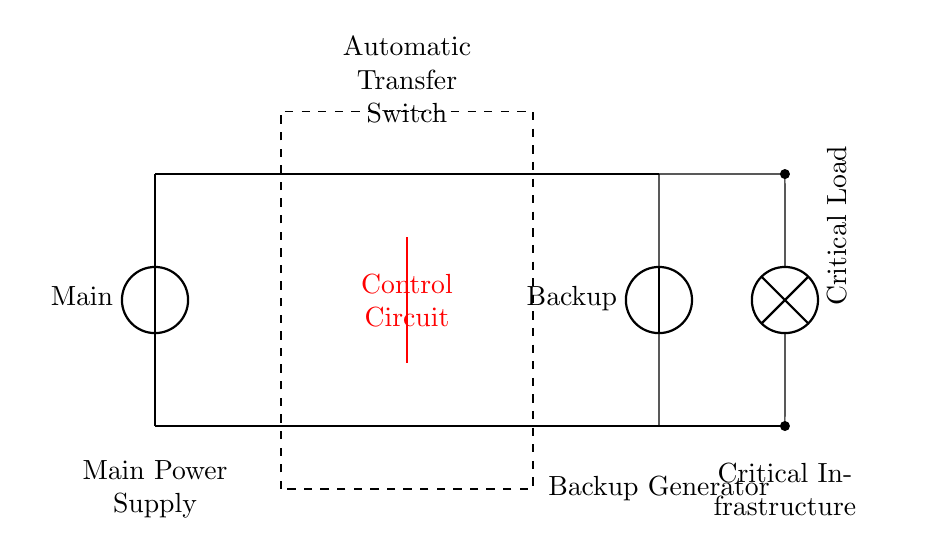What is the role of the Automatic Transfer Switch in this circuit? The Automatic Transfer Switch switches the load between the main power supply and the backup generator based on availability, ensuring uninterrupted power supply to critical infrastructure during emergencies.
Answer: Switching the load What type of load is represented in this circuit? The circuit diagram shows a critical load, which typically refers to essential electrical equipment that must remain operational even during power failures.
Answer: Critical load How many power sources are shown in the circuit? The diagram illustrates two power sources: the main power supply and the backup generator, which allows for redundancy in power delivery.
Answer: Two What does the red line represent in the circuit? The red line represents the control circuit that manages the operation of the Automatic Transfer Switch, determining when to switch between power sources.
Answer: Control circuit What is the voltage level for the Backup Generator in the circuit? The voltage level for the backup generator is not specified in the diagram, but it is assumed to be similar or compatible with the main power supply for effective operation.
Answer: Not specified What is the function of the dashed rectangle in the circuit? The dashed rectangle represents the physical enclosure or housing of the Automatic Transfer Switch, indicating its boundaries and containing its components for operation.
Answer: Enclosure of ATS Which component connects both power sources to the load? The Automatic Transfer Switch connects both the main power supply and the backup generator to the load, allowing it to direct power as needed.
Answer: Automatic Transfer Switch 